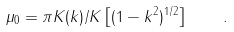<formula> <loc_0><loc_0><loc_500><loc_500>\mu _ { 0 } = \pi K ( k ) / K \left [ ( 1 - k ^ { 2 } ) ^ { 1 / 2 } \right ] \quad .</formula> 